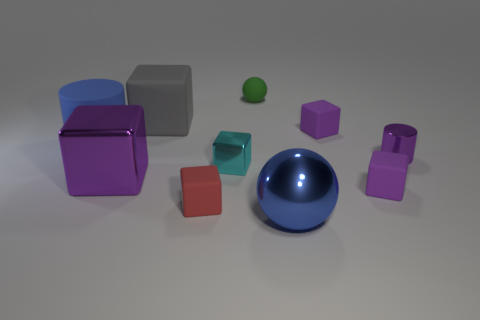What number of other things are there of the same material as the green thing
Provide a short and direct response. 5. Are any tiny brown metallic things visible?
Offer a terse response. No. Does the green thing have the same shape as the tiny cyan object?
Your answer should be very brief. No. There is a cylinder that is right of the tiny purple rubber thing that is in front of the purple metallic cube; how many cylinders are behind it?
Offer a terse response. 1. There is a big object that is both to the left of the green ball and in front of the big blue cylinder; what material is it?
Make the answer very short. Metal. What color is the metal thing that is both behind the large blue ball and right of the small green thing?
Keep it short and to the point. Purple. Is there anything else of the same color as the large matte cube?
Make the answer very short. No. What shape is the large thing that is to the right of the big thing that is behind the big blue object behind the cyan block?
Your answer should be compact. Sphere. What color is the other metallic thing that is the same shape as the big purple thing?
Offer a very short reply. Cyan. What color is the cylinder that is on the right side of the ball that is in front of the big blue rubber thing?
Keep it short and to the point. Purple. 